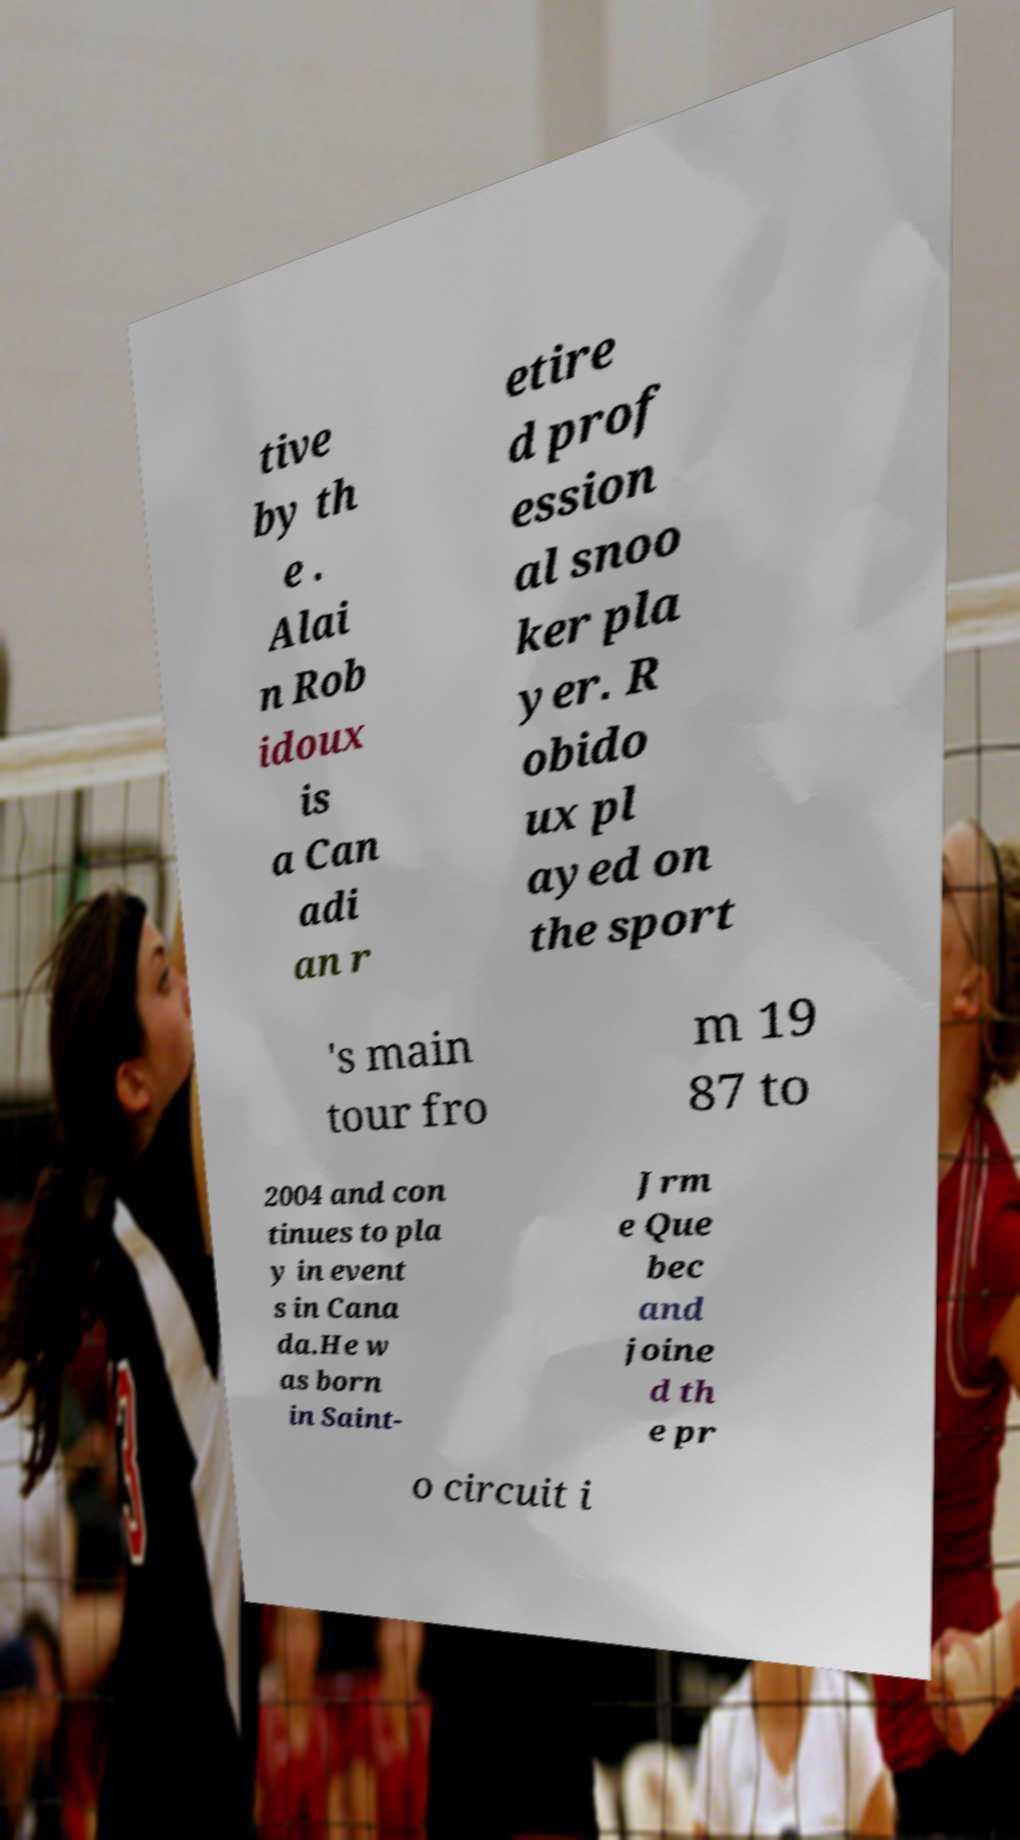There's text embedded in this image that I need extracted. Can you transcribe it verbatim? tive by th e . Alai n Rob idoux is a Can adi an r etire d prof ession al snoo ker pla yer. R obido ux pl ayed on the sport 's main tour fro m 19 87 to 2004 and con tinues to pla y in event s in Cana da.He w as born in Saint- Jrm e Que bec and joine d th e pr o circuit i 